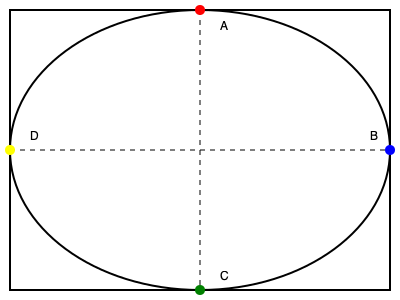In a 200m sprint on a standard 400m track, which point (A, B, C, or D) represents the correct starting position for the runners? To determine the correct starting position for a 200m sprint, we need to consider the following steps:

1. A standard 400m track consists of two straightaways and two curved sections.
2. The 200m sprint covers half of the track's total distance.
3. The race must end at the finish line, which is typically located at the end of one of the straightaways.
4. To ensure fairness, runners start on the curve to compensate for the staggered lanes.

Given these considerations:

- Point A is at the top of the track, which is not a typical starting position.
- Point C is at the bottom of the track, which would result in running more than half the track.
- Point D is at the beginning of a straightaway, which is not the correct starting position for a 200m race.
- Point B is at the beginning of the curve in the second half of the track.

Starting at Point B would allow runners to:
1. Begin on the curve, ensuring proper lane staggering.
2. Cover exactly half the track (200m).
3. Finish at the end of the straightaway where the finish line is typically located.

Therefore, Point B is the correct starting position for a 200m sprint on a standard 400m track.
Answer: B 